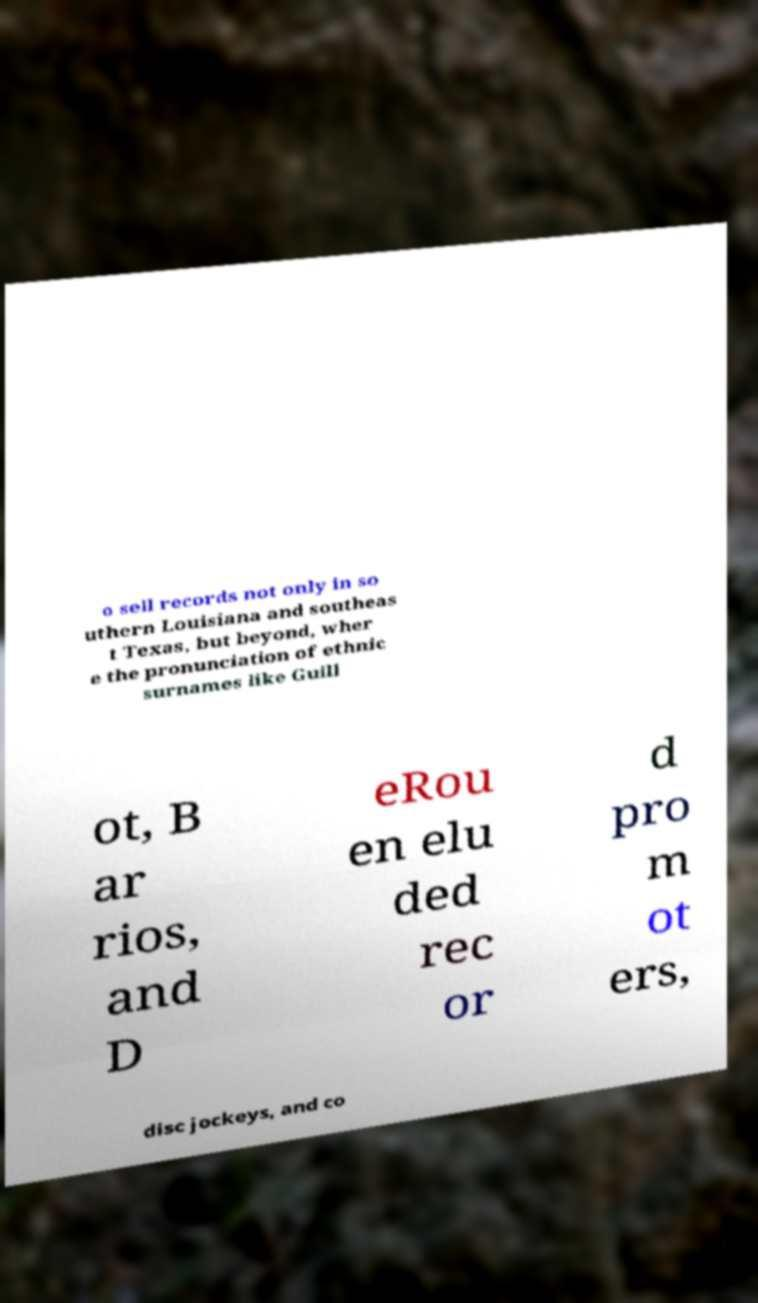Could you assist in decoding the text presented in this image and type it out clearly? o sell records not only in so uthern Louisiana and southeas t Texas, but beyond, wher e the pronunciation of ethnic surnames like Guill ot, B ar rios, and D eRou en elu ded rec or d pro m ot ers, disc jockeys, and co 